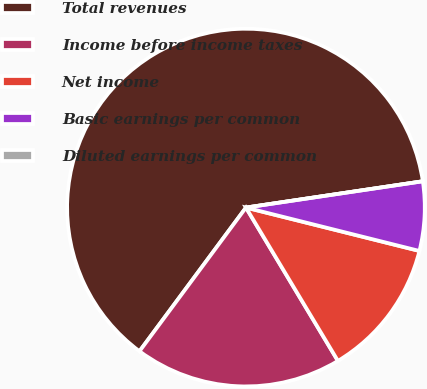<chart> <loc_0><loc_0><loc_500><loc_500><pie_chart><fcel>Total revenues<fcel>Income before income taxes<fcel>Net income<fcel>Basic earnings per common<fcel>Diluted earnings per common<nl><fcel>62.5%<fcel>18.75%<fcel>12.5%<fcel>6.25%<fcel>0.0%<nl></chart> 